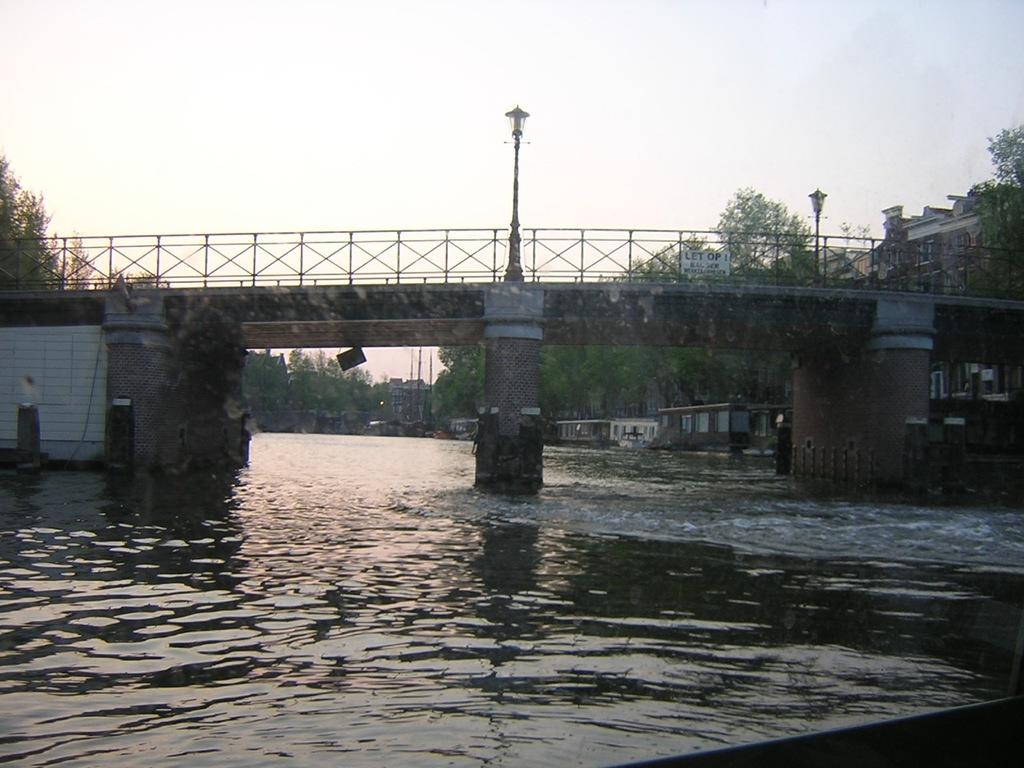What type of natural feature is present in the image? There is a river in the image. What structure is built over the river? There is a bridge over the river. What can be seen near the bridge in the image? The bridge has buildings and trees beside it. How many dolls are sitting on the bridge in the image? There are no dolls present in the image; it features a river, a bridge, buildings, and trees. What type of pet can be seen playing near the river in the image? There is no pet present in the image; it only features a river, a bridge, buildings, and trees. 